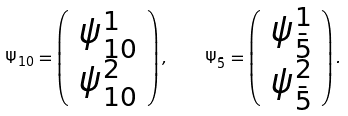<formula> <loc_0><loc_0><loc_500><loc_500>\Psi _ { 1 0 } = \left ( \begin{array} { c } \psi _ { 1 0 } ^ { 1 } \\ \psi _ { 1 0 } ^ { 2 } \end{array} \right ) , \quad \Psi _ { \bar { 5 } } = \left ( \begin{array} { c } \psi _ { \bar { 5 } } ^ { 1 } \\ \psi _ { \bar { 5 } } ^ { 2 } \end{array} \right ) .</formula> 